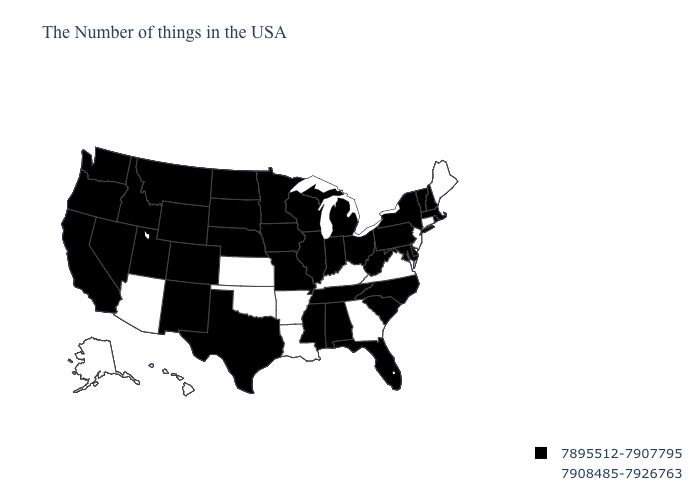What is the value of Missouri?
Be succinct. 7895512-7907795. What is the value of Kansas?
Concise answer only. 7908485-7926763. Name the states that have a value in the range 7908485-7926763?
Concise answer only. Maine, Connecticut, New Jersey, Virginia, Georgia, Kentucky, Louisiana, Arkansas, Kansas, Oklahoma, Arizona, Alaska, Hawaii. What is the highest value in states that border West Virginia?
Quick response, please. 7908485-7926763. Among the states that border New Mexico , which have the lowest value?
Keep it brief. Texas, Colorado, Utah. Does Michigan have a lower value than Louisiana?
Quick response, please. Yes. What is the highest value in the MidWest ?
Write a very short answer. 7908485-7926763. Does Maryland have the lowest value in the South?
Write a very short answer. Yes. Name the states that have a value in the range 7908485-7926763?
Write a very short answer. Maine, Connecticut, New Jersey, Virginia, Georgia, Kentucky, Louisiana, Arkansas, Kansas, Oklahoma, Arizona, Alaska, Hawaii. What is the highest value in states that border North Carolina?
Answer briefly. 7908485-7926763. What is the value of Nebraska?
Answer briefly. 7895512-7907795. What is the value of Iowa?
Keep it brief. 7895512-7907795. Name the states that have a value in the range 7908485-7926763?
Write a very short answer. Maine, Connecticut, New Jersey, Virginia, Georgia, Kentucky, Louisiana, Arkansas, Kansas, Oklahoma, Arizona, Alaska, Hawaii. Name the states that have a value in the range 7908485-7926763?
Concise answer only. Maine, Connecticut, New Jersey, Virginia, Georgia, Kentucky, Louisiana, Arkansas, Kansas, Oklahoma, Arizona, Alaska, Hawaii. 